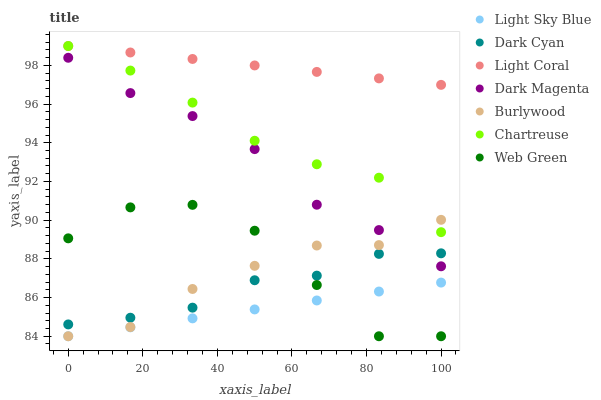Does Light Sky Blue have the minimum area under the curve?
Answer yes or no. Yes. Does Light Coral have the maximum area under the curve?
Answer yes or no. Yes. Does Burlywood have the minimum area under the curve?
Answer yes or no. No. Does Burlywood have the maximum area under the curve?
Answer yes or no. No. Is Light Coral the smoothest?
Answer yes or no. Yes. Is Web Green the roughest?
Answer yes or no. Yes. Is Burlywood the smoothest?
Answer yes or no. No. Is Burlywood the roughest?
Answer yes or no. No. Does Burlywood have the lowest value?
Answer yes or no. Yes. Does Light Coral have the lowest value?
Answer yes or no. No. Does Chartreuse have the highest value?
Answer yes or no. Yes. Does Burlywood have the highest value?
Answer yes or no. No. Is Web Green less than Light Coral?
Answer yes or no. Yes. Is Chartreuse greater than Dark Magenta?
Answer yes or no. Yes. Does Dark Magenta intersect Burlywood?
Answer yes or no. Yes. Is Dark Magenta less than Burlywood?
Answer yes or no. No. Is Dark Magenta greater than Burlywood?
Answer yes or no. No. Does Web Green intersect Light Coral?
Answer yes or no. No. 